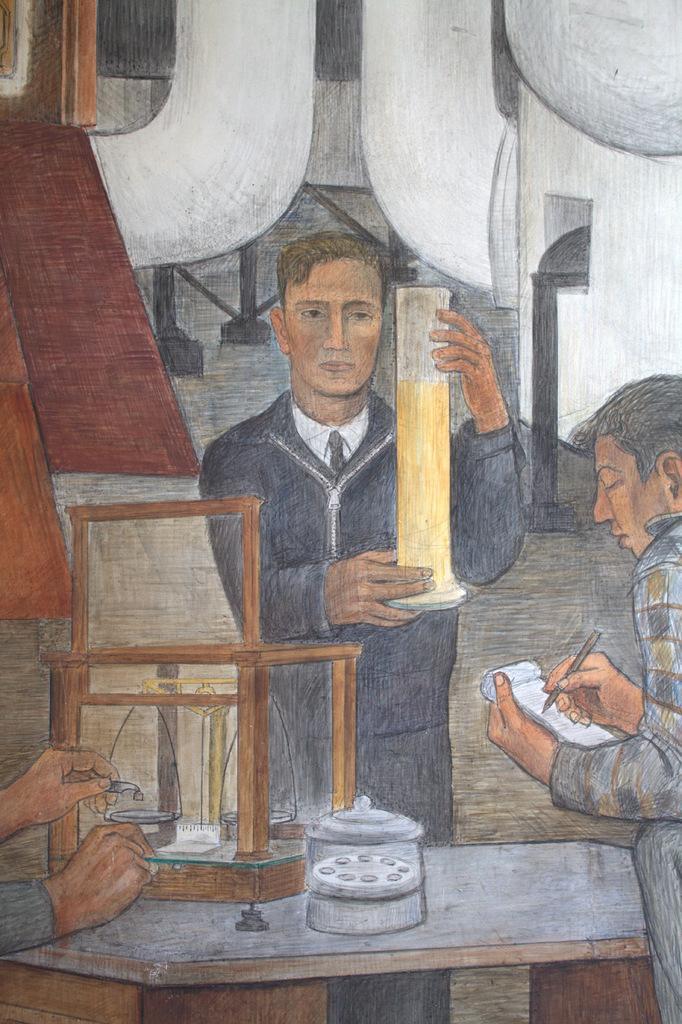How would you summarize this image in a sentence or two? In the middle of the picture I can see one person holding some object. On the right side of the picture I can see one person writing something on the book. In front of person I can see weight mission. And this is a drawing picture. 